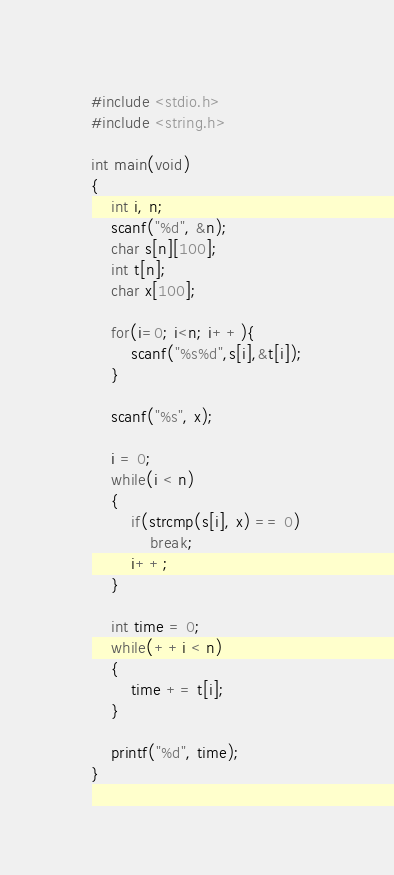<code> <loc_0><loc_0><loc_500><loc_500><_C_>#include <stdio.h>
#include <string.h>

int main(void)
{
	int i, n;
	scanf("%d", &n);
    char s[n][100];
    int t[n];
    char x[100];
    
	for(i=0; i<n; i++){
        scanf("%s%d",s[i],&t[i]);
	}
	
    scanf("%s", x);

    i = 0;
    while(i < n)
    {
        if(strcmp(s[i], x) == 0)
            break;
        i++;
    }

    int time = 0;
    while(++i < n)
    {
        time += t[i];
    }

    printf("%d", time);
}</code> 